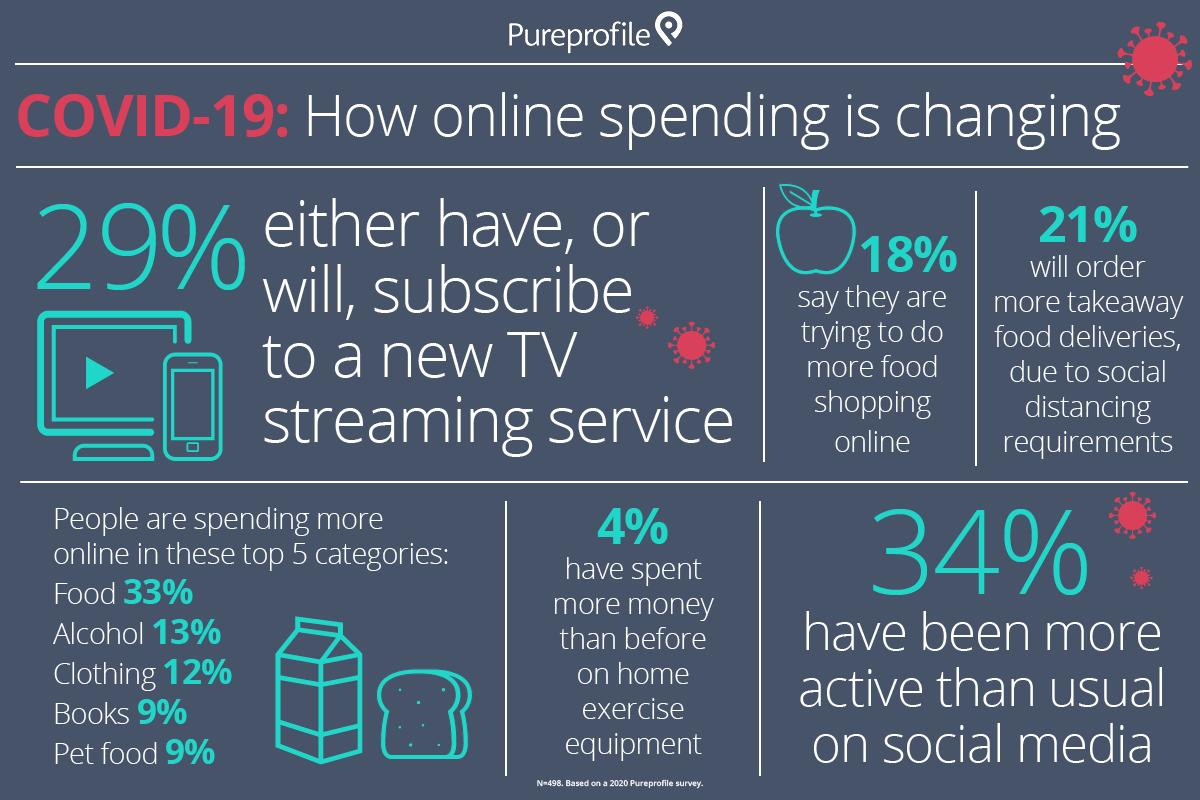Indicate a few pertinent items in this graphic. As a result of the pandemic, a significant percentage of people have shifted their book purchases online, with 9% citing COVID-19 as the primary reason for their decision. According to a survey, 18% of people report that they are now shopping for food online due to the impact of COVID-19. 